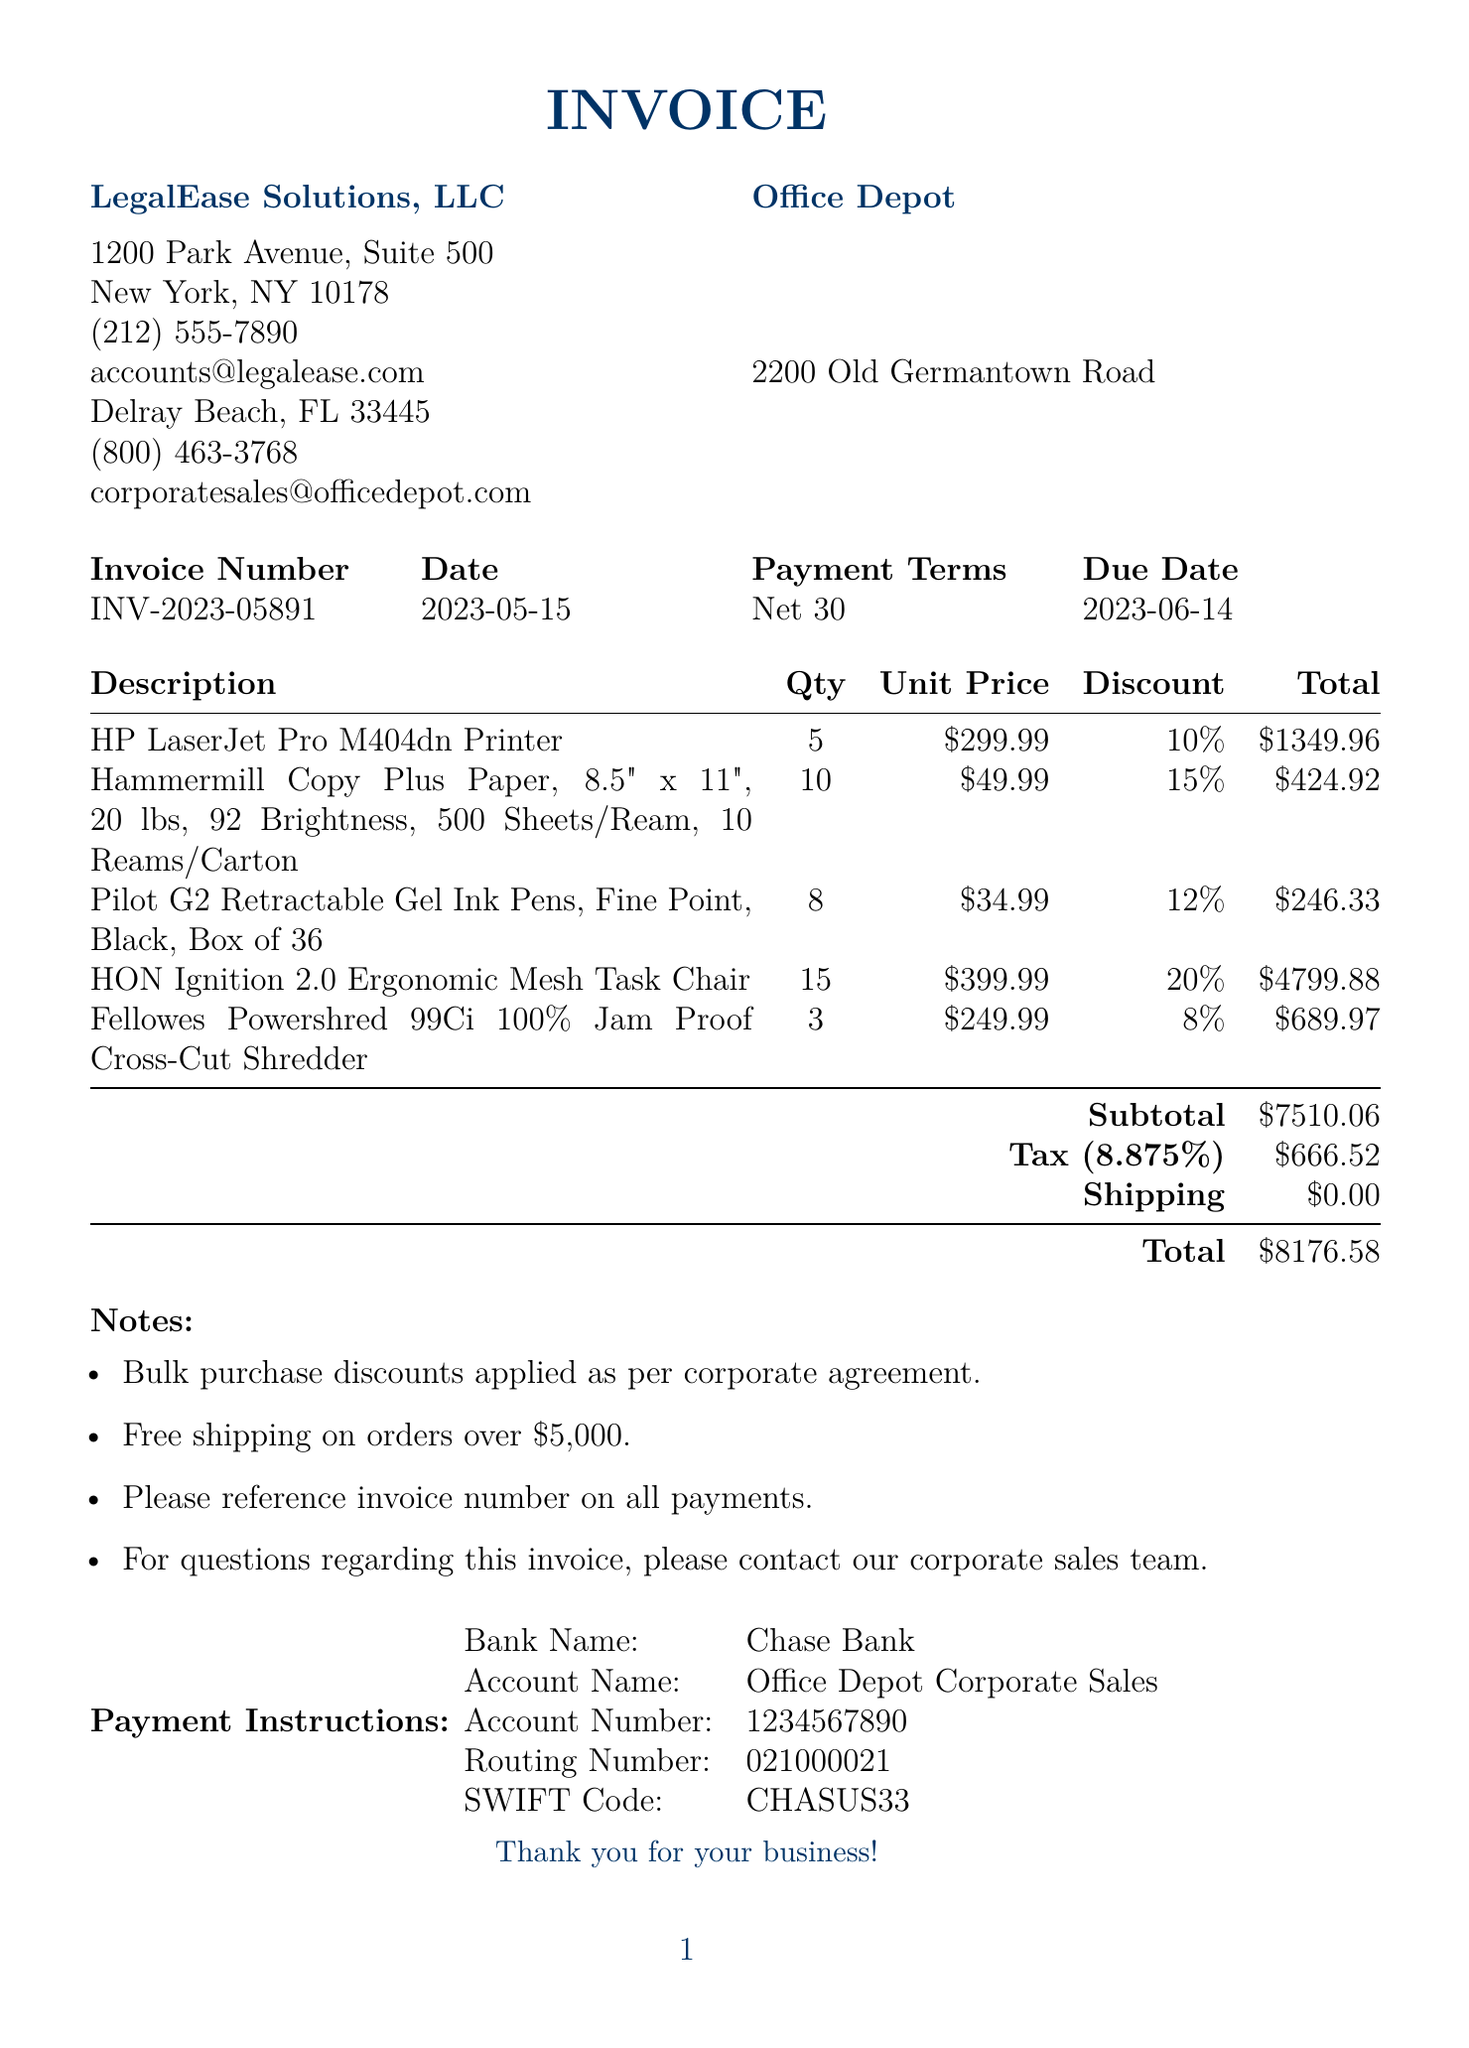What is the invoice number? The invoice number is explicitly stated in the document under invoice details.
Answer: INV-2023-05891 What is the due date of the invoice? The due date is mentioned in the invoice details section.
Answer: 2023-06-14 What is the total amount due? The total amount is the final figure listed at the bottom of the invoice.
Answer: $8176.58 How many HP LaserJet Pro M404dn Printers were purchased? The quantity of this specific item is indicated in the items section of the invoice.
Answer: 5 What discount percentage was applied to the HON Ignition 2.0 Ergonomic Mesh Task Chair? The discount percentage is specified next to the item in the items section.
Answer: 20% What is the subtotal amount before tax? The subtotal amount is displayed in the invoice before any taxes are added.
Answer: $7510.06 What payment terms are specified in the document? Payment terms are outlined in the invoice details, indicating the payment timeframe.
Answer: Net 30 Is there any shipping charge applied? The document states the shipping amount, which can indicate whether a charge was applied.
Answer: $0.00 What is the tax rate applied to the invoice? The tax rate is clearly indicated in the tax section of the invoice.
Answer: 8.875% 